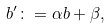<formula> <loc_0><loc_0><loc_500><loc_500>b ^ { \prime } \colon = \alpha b + \beta ,</formula> 